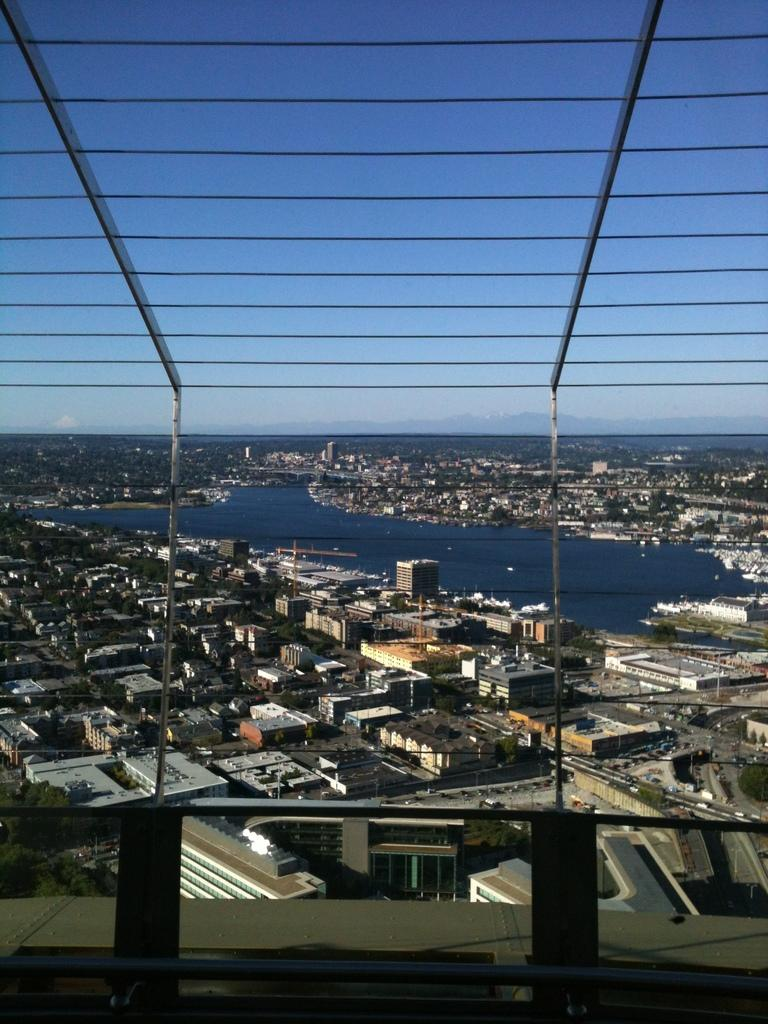What type of structures can be seen in the image? There are buildings in the image. What type of transportation infrastructure is present in the image? There are roads and vehicles visible in the image. What type of vertical structures can be seen in the image? There are poles in the image. What type of natural feature is visible in the image? There are hills in the image. What part of the natural environment is visible in the image? Water and sky are visible in the image. What type of atmospheric conditions can be observed in the image? There are clouds in the image. What type of dress is being worn by the oil in the image? There is no oil or dress present in the image. What is the wish of the clouds in the image? The image does not depict the clouds having any wishes; they are simply a natural atmospheric phenomenon. 